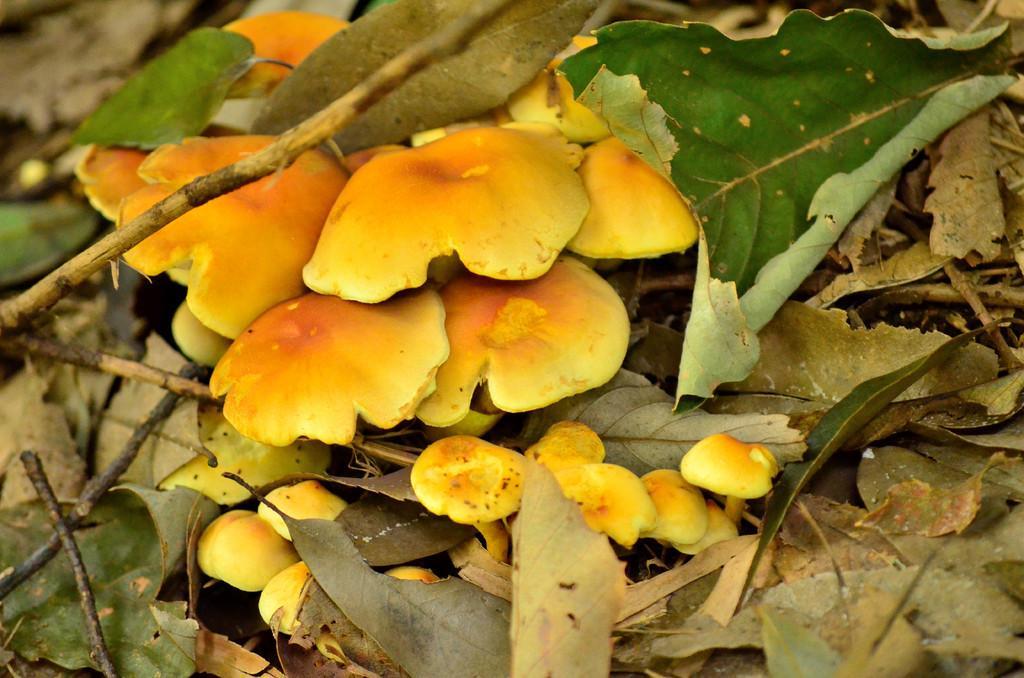Could you give a brief overview of what you see in this image? This picture shows mushrooms on the ground and we see leaves and mushrooms are white and brown in color. 